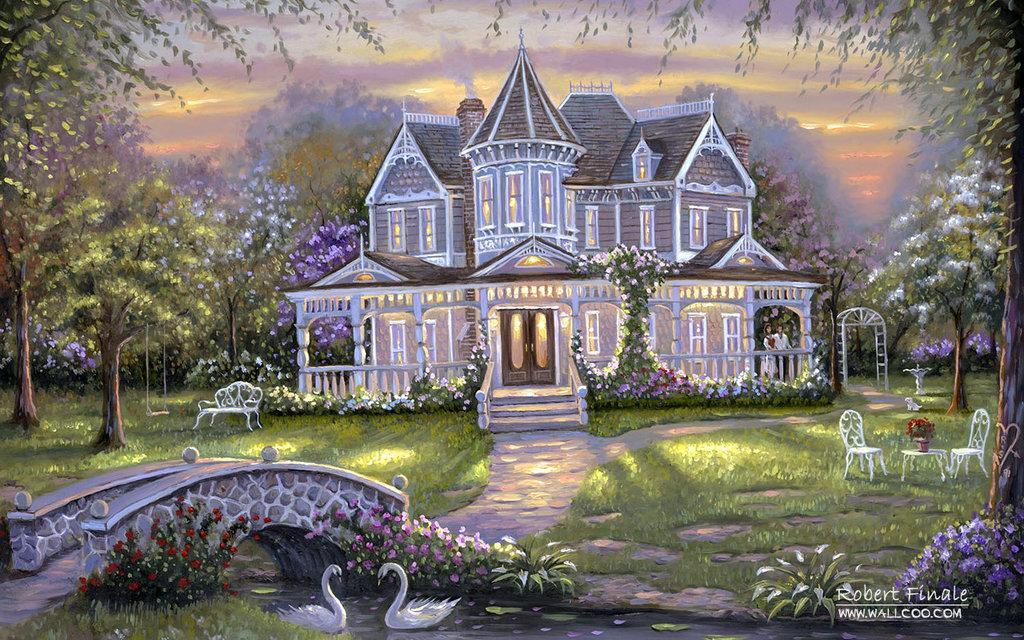Can you describe this image briefly? This image looks like a painting. In which there is a house and a garden. To the right, there are chairs and a table. To the left, there is a small bridge. At the bottom, there are swans. In the background, there are trees. 